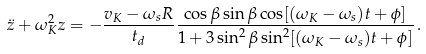<formula> <loc_0><loc_0><loc_500><loc_500>\ddot { z } + \omega _ { K } ^ { 2 } z = - \frac { v _ { K } - \omega _ { s } R } { t _ { d } } \frac { \cos \beta \sin \beta \cos [ ( \omega _ { K } - \omega _ { s } ) t + \phi ] } { 1 + 3 \sin ^ { 2 } \beta \sin ^ { 2 } [ ( \omega _ { K } - \omega _ { s } ) t + \phi ] } \, .</formula> 